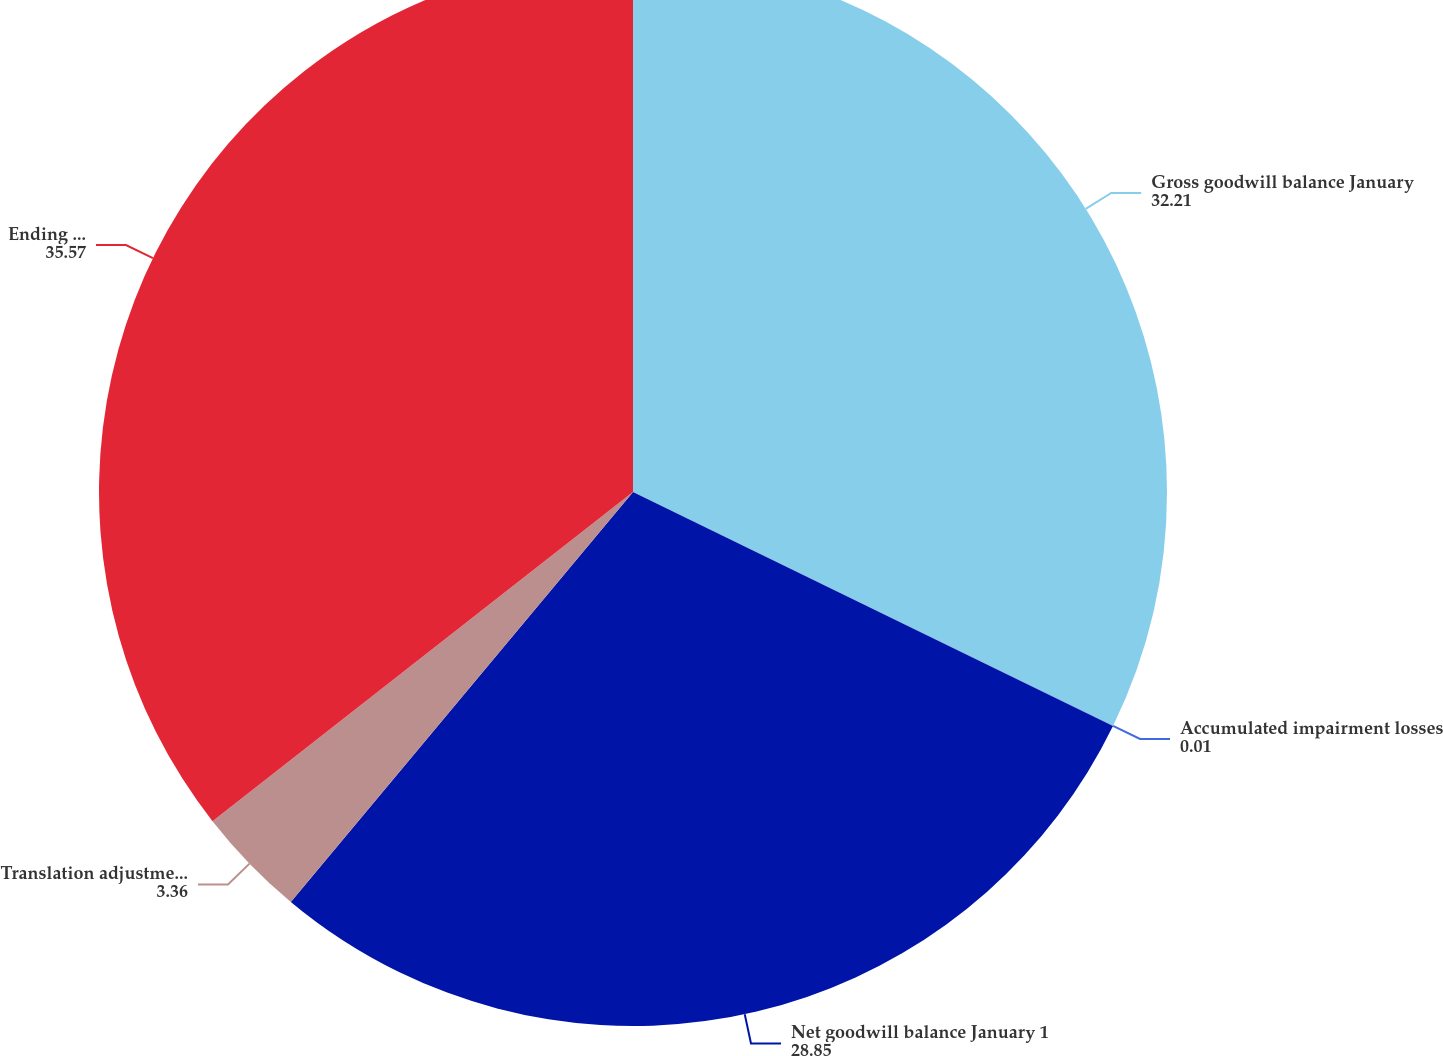Convert chart. <chart><loc_0><loc_0><loc_500><loc_500><pie_chart><fcel>Gross goodwill balance January<fcel>Accumulated impairment losses<fcel>Net goodwill balance January 1<fcel>Translation adjustment and<fcel>Ending balance December 31<nl><fcel>32.21%<fcel>0.01%<fcel>28.85%<fcel>3.36%<fcel>35.57%<nl></chart> 